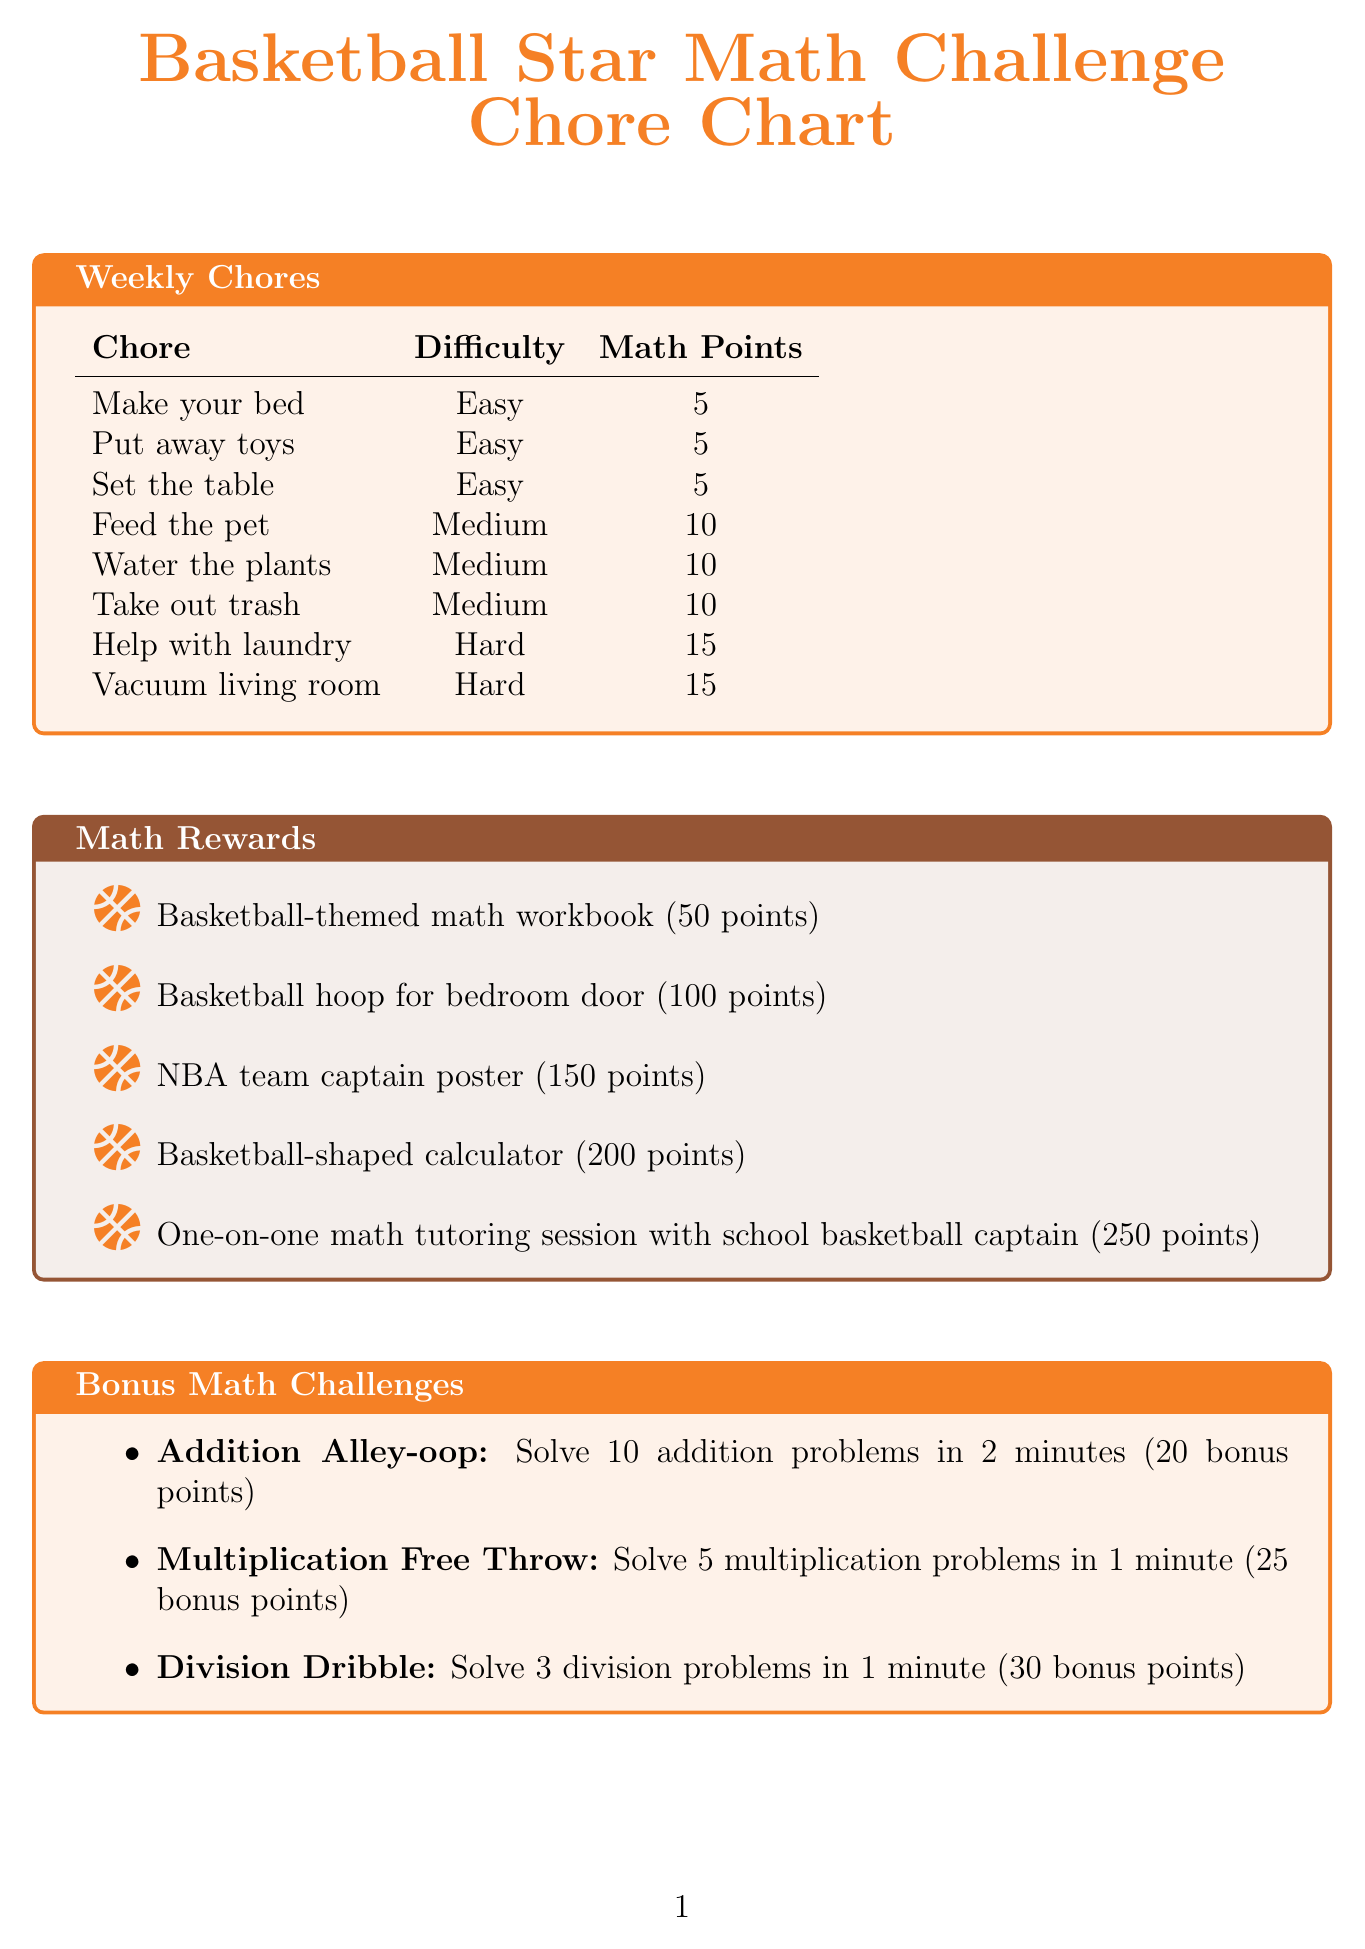What is the title of the chore chart? The title is explicitly stated at the top of the document.
Answer: Basketball Star Math Challenge Chore Chart How many math points do you earn for feeding the pet? The math points for each chore are listed in the chore table.
Answer: 10 What is the weekly goal for points? The weekly goal is specified in the progress tracking section of the document.
Answer: 100 What is the reward for 150 points? The rewards are listed along with their corresponding points required.
Answer: NBA team captain poster How many addition problems do you need to solve for the Addition Alley-oop challenge? The number of problems is stated in the description of the challenge.
Answer: 10 Which chore has the highest math points? This involves comparing all the math points assigned to each chore listed.
Answer: Help with laundry and Vacuum living room What are the total math points for completing all chores? The total points require adding all the math points for each chore.
Answer: 80 What bonus points do you get for completing the Division Dribble challenge? The bonus points are directly mentioned in the description of each challenge.
Answer: 30 Who can you have a one-on-one tutoring session with? The document specifies who can provide the tutoring session in the rewards section.
Answer: School basketball captain 